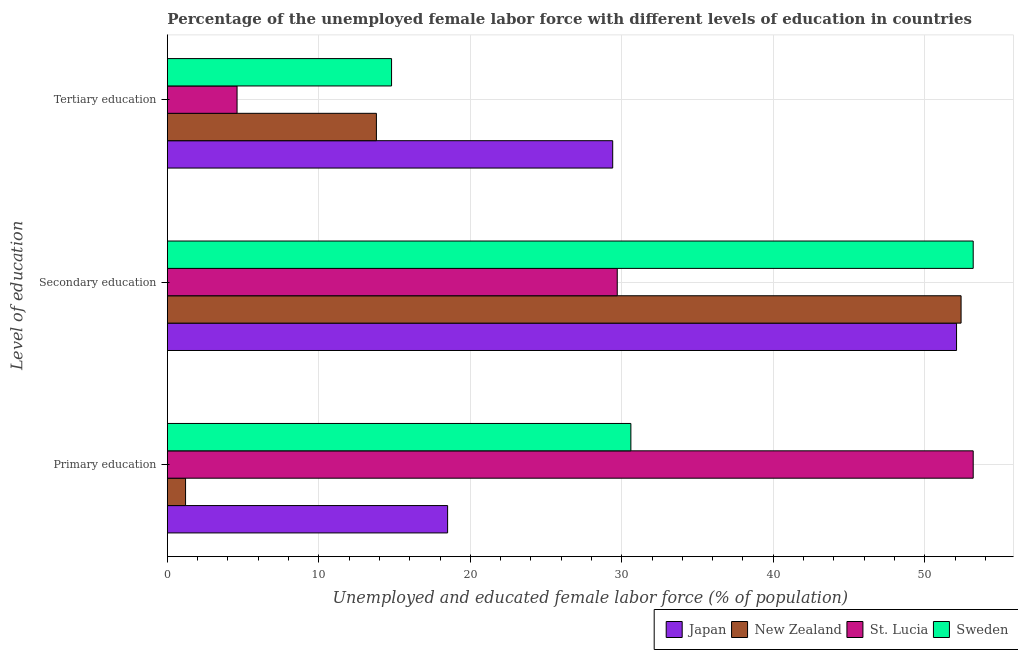How many groups of bars are there?
Make the answer very short. 3. Are the number of bars per tick equal to the number of legend labels?
Keep it short and to the point. Yes. Are the number of bars on each tick of the Y-axis equal?
Your answer should be compact. Yes. How many bars are there on the 3rd tick from the top?
Offer a very short reply. 4. How many bars are there on the 1st tick from the bottom?
Ensure brevity in your answer.  4. What is the label of the 2nd group of bars from the top?
Give a very brief answer. Secondary education. What is the percentage of female labor force who received primary education in Sweden?
Make the answer very short. 30.6. Across all countries, what is the maximum percentage of female labor force who received secondary education?
Provide a succinct answer. 53.2. Across all countries, what is the minimum percentage of female labor force who received secondary education?
Keep it short and to the point. 29.7. In which country was the percentage of female labor force who received tertiary education minimum?
Provide a short and direct response. St. Lucia. What is the total percentage of female labor force who received tertiary education in the graph?
Your answer should be compact. 62.6. What is the difference between the percentage of female labor force who received secondary education in Sweden and that in St. Lucia?
Keep it short and to the point. 23.5. What is the difference between the percentage of female labor force who received tertiary education in Sweden and the percentage of female labor force who received secondary education in Japan?
Keep it short and to the point. -37.3. What is the average percentage of female labor force who received tertiary education per country?
Give a very brief answer. 15.65. What is the difference between the percentage of female labor force who received primary education and percentage of female labor force who received tertiary education in New Zealand?
Make the answer very short. -12.6. What is the ratio of the percentage of female labor force who received primary education in St. Lucia to that in Japan?
Make the answer very short. 2.88. Is the difference between the percentage of female labor force who received secondary education in Sweden and Japan greater than the difference between the percentage of female labor force who received tertiary education in Sweden and Japan?
Your answer should be compact. Yes. What is the difference between the highest and the second highest percentage of female labor force who received secondary education?
Give a very brief answer. 0.8. What is the difference between the highest and the lowest percentage of female labor force who received tertiary education?
Your response must be concise. 24.8. What does the 2nd bar from the top in Tertiary education represents?
Your response must be concise. St. Lucia. What does the 3rd bar from the bottom in Secondary education represents?
Your answer should be compact. St. Lucia. How many countries are there in the graph?
Provide a succinct answer. 4. Where does the legend appear in the graph?
Offer a very short reply. Bottom right. How are the legend labels stacked?
Your answer should be very brief. Horizontal. What is the title of the graph?
Offer a very short reply. Percentage of the unemployed female labor force with different levels of education in countries. Does "Tajikistan" appear as one of the legend labels in the graph?
Give a very brief answer. No. What is the label or title of the X-axis?
Offer a very short reply. Unemployed and educated female labor force (% of population). What is the label or title of the Y-axis?
Offer a terse response. Level of education. What is the Unemployed and educated female labor force (% of population) in New Zealand in Primary education?
Your response must be concise. 1.2. What is the Unemployed and educated female labor force (% of population) in St. Lucia in Primary education?
Your answer should be very brief. 53.2. What is the Unemployed and educated female labor force (% of population) in Sweden in Primary education?
Keep it short and to the point. 30.6. What is the Unemployed and educated female labor force (% of population) in Japan in Secondary education?
Ensure brevity in your answer.  52.1. What is the Unemployed and educated female labor force (% of population) of New Zealand in Secondary education?
Make the answer very short. 52.4. What is the Unemployed and educated female labor force (% of population) in St. Lucia in Secondary education?
Ensure brevity in your answer.  29.7. What is the Unemployed and educated female labor force (% of population) of Sweden in Secondary education?
Your answer should be very brief. 53.2. What is the Unemployed and educated female labor force (% of population) in Japan in Tertiary education?
Your response must be concise. 29.4. What is the Unemployed and educated female labor force (% of population) in New Zealand in Tertiary education?
Your response must be concise. 13.8. What is the Unemployed and educated female labor force (% of population) in St. Lucia in Tertiary education?
Your response must be concise. 4.6. What is the Unemployed and educated female labor force (% of population) in Sweden in Tertiary education?
Offer a terse response. 14.8. Across all Level of education, what is the maximum Unemployed and educated female labor force (% of population) in Japan?
Give a very brief answer. 52.1. Across all Level of education, what is the maximum Unemployed and educated female labor force (% of population) in New Zealand?
Offer a very short reply. 52.4. Across all Level of education, what is the maximum Unemployed and educated female labor force (% of population) in St. Lucia?
Your answer should be compact. 53.2. Across all Level of education, what is the maximum Unemployed and educated female labor force (% of population) in Sweden?
Keep it short and to the point. 53.2. Across all Level of education, what is the minimum Unemployed and educated female labor force (% of population) in New Zealand?
Offer a terse response. 1.2. Across all Level of education, what is the minimum Unemployed and educated female labor force (% of population) in St. Lucia?
Keep it short and to the point. 4.6. Across all Level of education, what is the minimum Unemployed and educated female labor force (% of population) of Sweden?
Make the answer very short. 14.8. What is the total Unemployed and educated female labor force (% of population) in New Zealand in the graph?
Ensure brevity in your answer.  67.4. What is the total Unemployed and educated female labor force (% of population) in St. Lucia in the graph?
Offer a terse response. 87.5. What is the total Unemployed and educated female labor force (% of population) of Sweden in the graph?
Your answer should be compact. 98.6. What is the difference between the Unemployed and educated female labor force (% of population) of Japan in Primary education and that in Secondary education?
Make the answer very short. -33.6. What is the difference between the Unemployed and educated female labor force (% of population) in New Zealand in Primary education and that in Secondary education?
Your answer should be compact. -51.2. What is the difference between the Unemployed and educated female labor force (% of population) of Sweden in Primary education and that in Secondary education?
Provide a short and direct response. -22.6. What is the difference between the Unemployed and educated female labor force (% of population) in Japan in Primary education and that in Tertiary education?
Give a very brief answer. -10.9. What is the difference between the Unemployed and educated female labor force (% of population) of St. Lucia in Primary education and that in Tertiary education?
Give a very brief answer. 48.6. What is the difference between the Unemployed and educated female labor force (% of population) in Sweden in Primary education and that in Tertiary education?
Offer a terse response. 15.8. What is the difference between the Unemployed and educated female labor force (% of population) in Japan in Secondary education and that in Tertiary education?
Offer a very short reply. 22.7. What is the difference between the Unemployed and educated female labor force (% of population) of New Zealand in Secondary education and that in Tertiary education?
Give a very brief answer. 38.6. What is the difference between the Unemployed and educated female labor force (% of population) in St. Lucia in Secondary education and that in Tertiary education?
Keep it short and to the point. 25.1. What is the difference between the Unemployed and educated female labor force (% of population) in Sweden in Secondary education and that in Tertiary education?
Give a very brief answer. 38.4. What is the difference between the Unemployed and educated female labor force (% of population) of Japan in Primary education and the Unemployed and educated female labor force (% of population) of New Zealand in Secondary education?
Make the answer very short. -33.9. What is the difference between the Unemployed and educated female labor force (% of population) in Japan in Primary education and the Unemployed and educated female labor force (% of population) in St. Lucia in Secondary education?
Ensure brevity in your answer.  -11.2. What is the difference between the Unemployed and educated female labor force (% of population) in Japan in Primary education and the Unemployed and educated female labor force (% of population) in Sweden in Secondary education?
Provide a short and direct response. -34.7. What is the difference between the Unemployed and educated female labor force (% of population) in New Zealand in Primary education and the Unemployed and educated female labor force (% of population) in St. Lucia in Secondary education?
Offer a very short reply. -28.5. What is the difference between the Unemployed and educated female labor force (% of population) of New Zealand in Primary education and the Unemployed and educated female labor force (% of population) of Sweden in Secondary education?
Give a very brief answer. -52. What is the difference between the Unemployed and educated female labor force (% of population) of St. Lucia in Primary education and the Unemployed and educated female labor force (% of population) of Sweden in Secondary education?
Provide a succinct answer. 0. What is the difference between the Unemployed and educated female labor force (% of population) in Japan in Primary education and the Unemployed and educated female labor force (% of population) in New Zealand in Tertiary education?
Give a very brief answer. 4.7. What is the difference between the Unemployed and educated female labor force (% of population) of Japan in Primary education and the Unemployed and educated female labor force (% of population) of St. Lucia in Tertiary education?
Keep it short and to the point. 13.9. What is the difference between the Unemployed and educated female labor force (% of population) of Japan in Primary education and the Unemployed and educated female labor force (% of population) of Sweden in Tertiary education?
Ensure brevity in your answer.  3.7. What is the difference between the Unemployed and educated female labor force (% of population) in New Zealand in Primary education and the Unemployed and educated female labor force (% of population) in St. Lucia in Tertiary education?
Offer a very short reply. -3.4. What is the difference between the Unemployed and educated female labor force (% of population) in New Zealand in Primary education and the Unemployed and educated female labor force (% of population) in Sweden in Tertiary education?
Keep it short and to the point. -13.6. What is the difference between the Unemployed and educated female labor force (% of population) in St. Lucia in Primary education and the Unemployed and educated female labor force (% of population) in Sweden in Tertiary education?
Provide a succinct answer. 38.4. What is the difference between the Unemployed and educated female labor force (% of population) of Japan in Secondary education and the Unemployed and educated female labor force (% of population) of New Zealand in Tertiary education?
Make the answer very short. 38.3. What is the difference between the Unemployed and educated female labor force (% of population) in Japan in Secondary education and the Unemployed and educated female labor force (% of population) in St. Lucia in Tertiary education?
Make the answer very short. 47.5. What is the difference between the Unemployed and educated female labor force (% of population) in Japan in Secondary education and the Unemployed and educated female labor force (% of population) in Sweden in Tertiary education?
Keep it short and to the point. 37.3. What is the difference between the Unemployed and educated female labor force (% of population) of New Zealand in Secondary education and the Unemployed and educated female labor force (% of population) of St. Lucia in Tertiary education?
Provide a succinct answer. 47.8. What is the difference between the Unemployed and educated female labor force (% of population) in New Zealand in Secondary education and the Unemployed and educated female labor force (% of population) in Sweden in Tertiary education?
Offer a terse response. 37.6. What is the average Unemployed and educated female labor force (% of population) of Japan per Level of education?
Provide a short and direct response. 33.33. What is the average Unemployed and educated female labor force (% of population) in New Zealand per Level of education?
Ensure brevity in your answer.  22.47. What is the average Unemployed and educated female labor force (% of population) of St. Lucia per Level of education?
Keep it short and to the point. 29.17. What is the average Unemployed and educated female labor force (% of population) of Sweden per Level of education?
Your answer should be very brief. 32.87. What is the difference between the Unemployed and educated female labor force (% of population) in Japan and Unemployed and educated female labor force (% of population) in New Zealand in Primary education?
Make the answer very short. 17.3. What is the difference between the Unemployed and educated female labor force (% of population) in Japan and Unemployed and educated female labor force (% of population) in St. Lucia in Primary education?
Your answer should be compact. -34.7. What is the difference between the Unemployed and educated female labor force (% of population) of New Zealand and Unemployed and educated female labor force (% of population) of St. Lucia in Primary education?
Make the answer very short. -52. What is the difference between the Unemployed and educated female labor force (% of population) in New Zealand and Unemployed and educated female labor force (% of population) in Sweden in Primary education?
Give a very brief answer. -29.4. What is the difference between the Unemployed and educated female labor force (% of population) in St. Lucia and Unemployed and educated female labor force (% of population) in Sweden in Primary education?
Provide a succinct answer. 22.6. What is the difference between the Unemployed and educated female labor force (% of population) of Japan and Unemployed and educated female labor force (% of population) of St. Lucia in Secondary education?
Your response must be concise. 22.4. What is the difference between the Unemployed and educated female labor force (% of population) of Japan and Unemployed and educated female labor force (% of population) of Sweden in Secondary education?
Offer a very short reply. -1.1. What is the difference between the Unemployed and educated female labor force (% of population) of New Zealand and Unemployed and educated female labor force (% of population) of St. Lucia in Secondary education?
Keep it short and to the point. 22.7. What is the difference between the Unemployed and educated female labor force (% of population) of St. Lucia and Unemployed and educated female labor force (% of population) of Sweden in Secondary education?
Give a very brief answer. -23.5. What is the difference between the Unemployed and educated female labor force (% of population) in Japan and Unemployed and educated female labor force (% of population) in New Zealand in Tertiary education?
Make the answer very short. 15.6. What is the difference between the Unemployed and educated female labor force (% of population) in Japan and Unemployed and educated female labor force (% of population) in St. Lucia in Tertiary education?
Your response must be concise. 24.8. What is the difference between the Unemployed and educated female labor force (% of population) of Japan and Unemployed and educated female labor force (% of population) of Sweden in Tertiary education?
Ensure brevity in your answer.  14.6. What is the difference between the Unemployed and educated female labor force (% of population) in New Zealand and Unemployed and educated female labor force (% of population) in Sweden in Tertiary education?
Your response must be concise. -1. What is the ratio of the Unemployed and educated female labor force (% of population) in Japan in Primary education to that in Secondary education?
Ensure brevity in your answer.  0.36. What is the ratio of the Unemployed and educated female labor force (% of population) of New Zealand in Primary education to that in Secondary education?
Provide a short and direct response. 0.02. What is the ratio of the Unemployed and educated female labor force (% of population) of St. Lucia in Primary education to that in Secondary education?
Provide a short and direct response. 1.79. What is the ratio of the Unemployed and educated female labor force (% of population) of Sweden in Primary education to that in Secondary education?
Your answer should be compact. 0.58. What is the ratio of the Unemployed and educated female labor force (% of population) in Japan in Primary education to that in Tertiary education?
Ensure brevity in your answer.  0.63. What is the ratio of the Unemployed and educated female labor force (% of population) in New Zealand in Primary education to that in Tertiary education?
Provide a short and direct response. 0.09. What is the ratio of the Unemployed and educated female labor force (% of population) of St. Lucia in Primary education to that in Tertiary education?
Ensure brevity in your answer.  11.57. What is the ratio of the Unemployed and educated female labor force (% of population) in Sweden in Primary education to that in Tertiary education?
Ensure brevity in your answer.  2.07. What is the ratio of the Unemployed and educated female labor force (% of population) in Japan in Secondary education to that in Tertiary education?
Offer a very short reply. 1.77. What is the ratio of the Unemployed and educated female labor force (% of population) in New Zealand in Secondary education to that in Tertiary education?
Give a very brief answer. 3.8. What is the ratio of the Unemployed and educated female labor force (% of population) of St. Lucia in Secondary education to that in Tertiary education?
Ensure brevity in your answer.  6.46. What is the ratio of the Unemployed and educated female labor force (% of population) in Sweden in Secondary education to that in Tertiary education?
Your answer should be very brief. 3.59. What is the difference between the highest and the second highest Unemployed and educated female labor force (% of population) of Japan?
Your answer should be compact. 22.7. What is the difference between the highest and the second highest Unemployed and educated female labor force (% of population) in New Zealand?
Your answer should be very brief. 38.6. What is the difference between the highest and the second highest Unemployed and educated female labor force (% of population) of St. Lucia?
Your response must be concise. 23.5. What is the difference between the highest and the second highest Unemployed and educated female labor force (% of population) in Sweden?
Give a very brief answer. 22.6. What is the difference between the highest and the lowest Unemployed and educated female labor force (% of population) of Japan?
Ensure brevity in your answer.  33.6. What is the difference between the highest and the lowest Unemployed and educated female labor force (% of population) of New Zealand?
Keep it short and to the point. 51.2. What is the difference between the highest and the lowest Unemployed and educated female labor force (% of population) of St. Lucia?
Keep it short and to the point. 48.6. What is the difference between the highest and the lowest Unemployed and educated female labor force (% of population) in Sweden?
Your answer should be very brief. 38.4. 